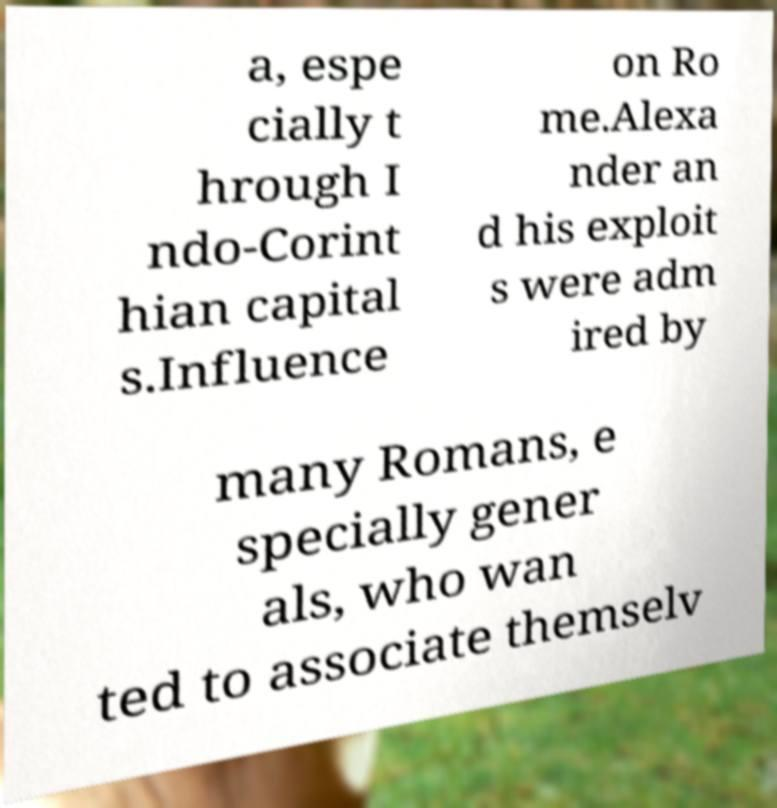What messages or text are displayed in this image? I need them in a readable, typed format. a, espe cially t hrough I ndo-Corint hian capital s.Influence on Ro me.Alexa nder an d his exploit s were adm ired by many Romans, e specially gener als, who wan ted to associate themselv 